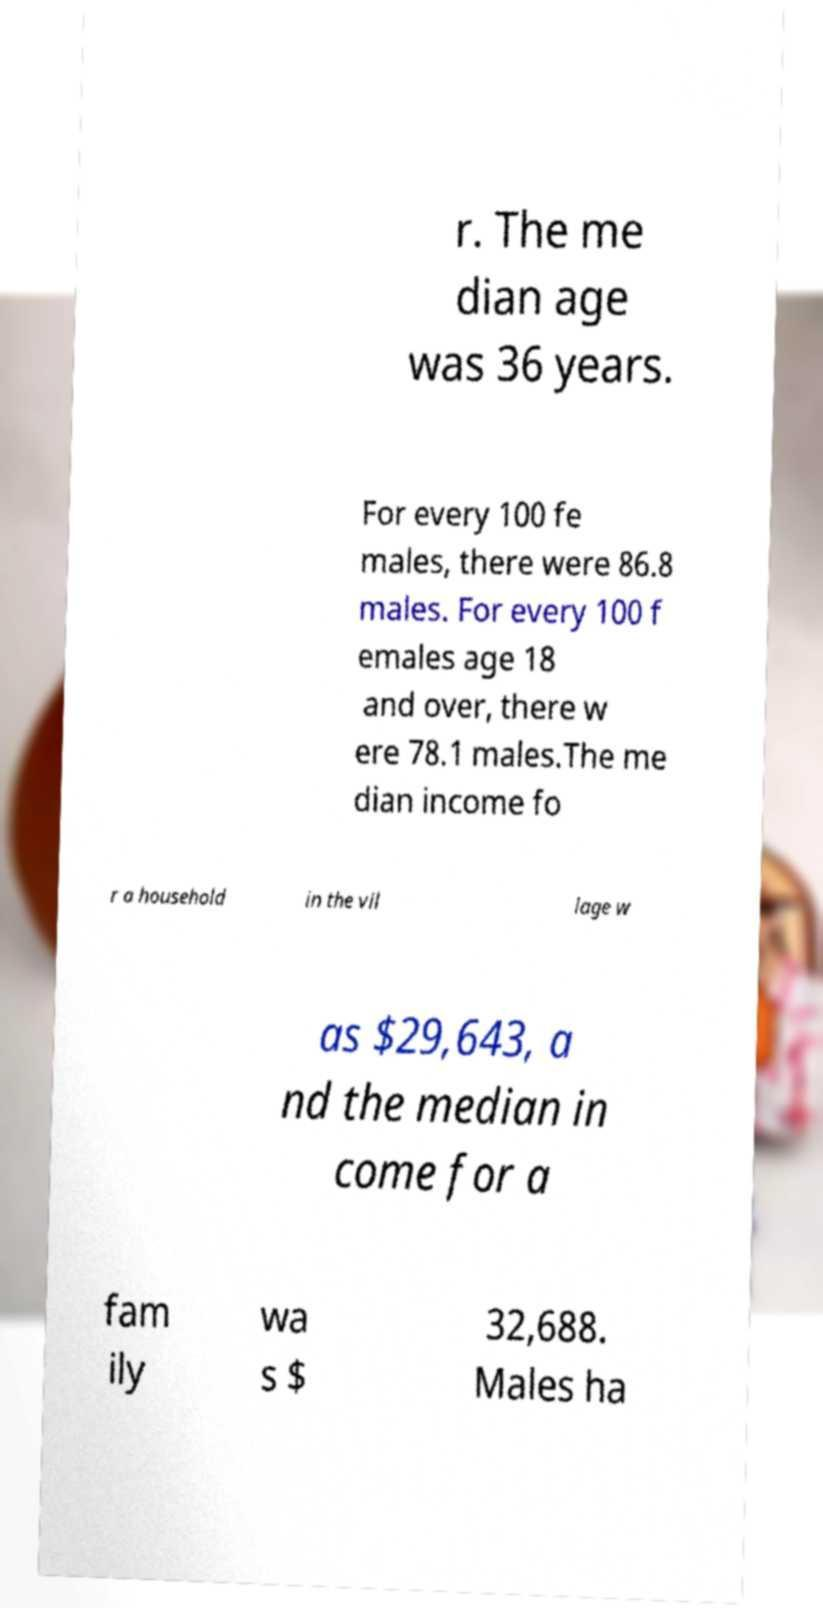There's text embedded in this image that I need extracted. Can you transcribe it verbatim? r. The me dian age was 36 years. For every 100 fe males, there were 86.8 males. For every 100 f emales age 18 and over, there w ere 78.1 males.The me dian income fo r a household in the vil lage w as $29,643, a nd the median in come for a fam ily wa s $ 32,688. Males ha 